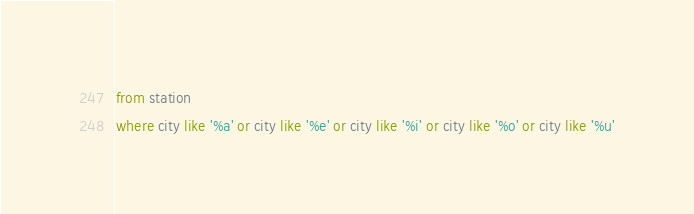<code> <loc_0><loc_0><loc_500><loc_500><_SQL_>from station 
where city like '%a' or city like '%e' or city like '%i' or city like '%o' or city like '%u'</code> 